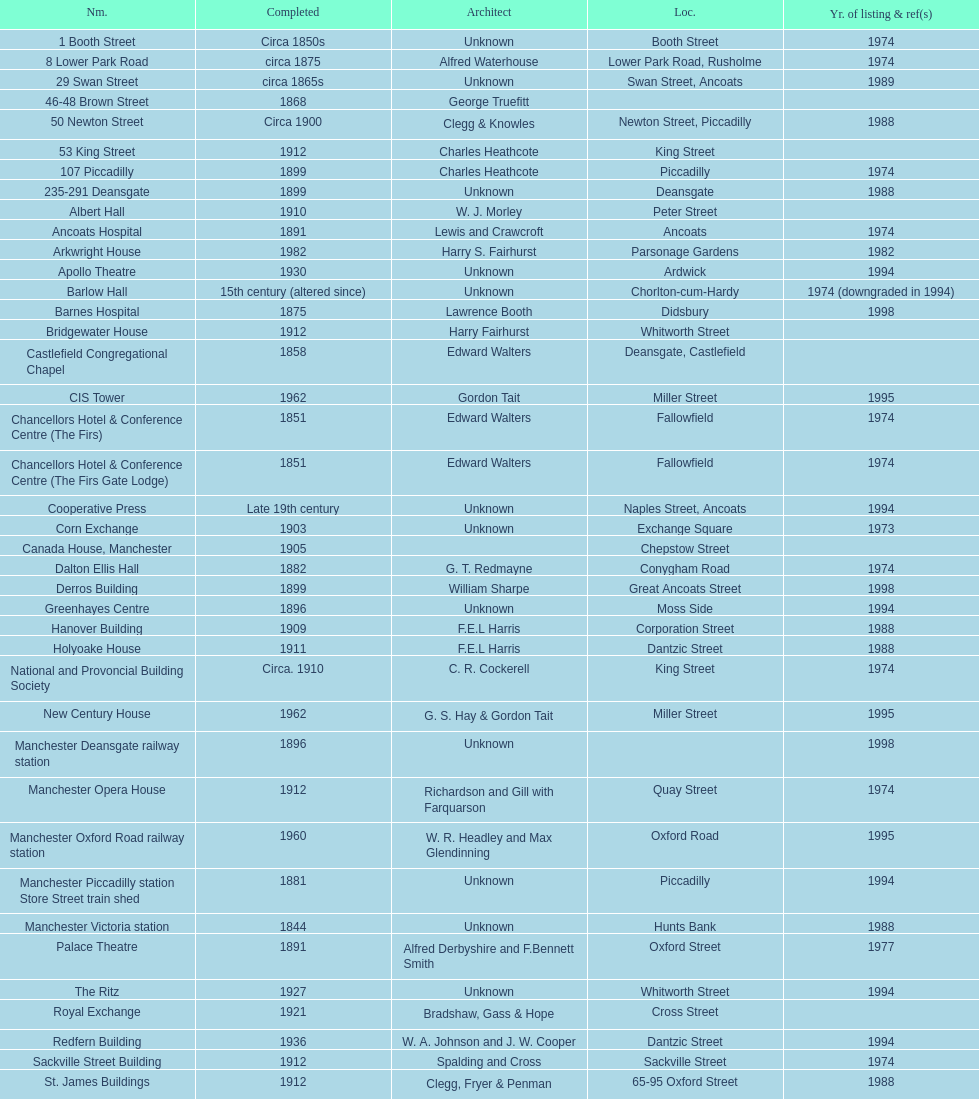Which two buildings were listed before 1974? The Old Wellington Inn, Smithfield Market Hall. Parse the table in full. {'header': ['Nm.', 'Completed', 'Architect', 'Loc.', 'Yr. of listing & ref(s)'], 'rows': [['1 Booth Street', 'Circa 1850s', 'Unknown', 'Booth Street', '1974'], ['8 Lower Park Road', 'circa 1875', 'Alfred Waterhouse', 'Lower Park Road, Rusholme', '1974'], ['29 Swan Street', 'circa 1865s', 'Unknown', 'Swan Street, Ancoats', '1989'], ['46-48 Brown Street', '1868', 'George Truefitt', '', ''], ['50 Newton Street', 'Circa 1900', 'Clegg & Knowles', 'Newton Street, Piccadilly', '1988'], ['53 King Street', '1912', 'Charles Heathcote', 'King Street', ''], ['107 Piccadilly', '1899', 'Charles Heathcote', 'Piccadilly', '1974'], ['235-291 Deansgate', '1899', 'Unknown', 'Deansgate', '1988'], ['Albert Hall', '1910', 'W. J. Morley', 'Peter Street', ''], ['Ancoats Hospital', '1891', 'Lewis and Crawcroft', 'Ancoats', '1974'], ['Arkwright House', '1982', 'Harry S. Fairhurst', 'Parsonage Gardens', '1982'], ['Apollo Theatre', '1930', 'Unknown', 'Ardwick', '1994'], ['Barlow Hall', '15th century (altered since)', 'Unknown', 'Chorlton-cum-Hardy', '1974 (downgraded in 1994)'], ['Barnes Hospital', '1875', 'Lawrence Booth', 'Didsbury', '1998'], ['Bridgewater House', '1912', 'Harry Fairhurst', 'Whitworth Street', ''], ['Castlefield Congregational Chapel', '1858', 'Edward Walters', 'Deansgate, Castlefield', ''], ['CIS Tower', '1962', 'Gordon Tait', 'Miller Street', '1995'], ['Chancellors Hotel & Conference Centre (The Firs)', '1851', 'Edward Walters', 'Fallowfield', '1974'], ['Chancellors Hotel & Conference Centre (The Firs Gate Lodge)', '1851', 'Edward Walters', 'Fallowfield', '1974'], ['Cooperative Press', 'Late 19th century', 'Unknown', 'Naples Street, Ancoats', '1994'], ['Corn Exchange', '1903', 'Unknown', 'Exchange Square', '1973'], ['Canada House, Manchester', '1905', '', 'Chepstow Street', ''], ['Dalton Ellis Hall', '1882', 'G. T. Redmayne', 'Conygham Road', '1974'], ['Derros Building', '1899', 'William Sharpe', 'Great Ancoats Street', '1998'], ['Greenhayes Centre', '1896', 'Unknown', 'Moss Side', '1994'], ['Hanover Building', '1909', 'F.E.L Harris', 'Corporation Street', '1988'], ['Holyoake House', '1911', 'F.E.L Harris', 'Dantzic Street', '1988'], ['National and Provoncial Building Society', 'Circa. 1910', 'C. R. Cockerell', 'King Street', '1974'], ['New Century House', '1962', 'G. S. Hay & Gordon Tait', 'Miller Street', '1995'], ['Manchester Deansgate railway station', '1896', 'Unknown', '', '1998'], ['Manchester Opera House', '1912', 'Richardson and Gill with Farquarson', 'Quay Street', '1974'], ['Manchester Oxford Road railway station', '1960', 'W. R. Headley and Max Glendinning', 'Oxford Road', '1995'], ['Manchester Piccadilly station Store Street train shed', '1881', 'Unknown', 'Piccadilly', '1994'], ['Manchester Victoria station', '1844', 'Unknown', 'Hunts Bank', '1988'], ['Palace Theatre', '1891', 'Alfred Derbyshire and F.Bennett Smith', 'Oxford Street', '1977'], ['The Ritz', '1927', 'Unknown', 'Whitworth Street', '1994'], ['Royal Exchange', '1921', 'Bradshaw, Gass & Hope', 'Cross Street', ''], ['Redfern Building', '1936', 'W. A. Johnson and J. W. Cooper', 'Dantzic Street', '1994'], ['Sackville Street Building', '1912', 'Spalding and Cross', 'Sackville Street', '1974'], ['St. James Buildings', '1912', 'Clegg, Fryer & Penman', '65-95 Oxford Street', '1988'], ["St Mary's Hospital", '1909', 'John Ely', 'Wilmslow Road', '1994'], ['Samuel Alexander Building', '1919', 'Percy Scott Worthington', 'Oxford Road', '2010'], ['Ship Canal House', '1927', 'Harry S. Fairhurst', 'King Street', '1982'], ['Smithfield Market Hall', '1857', 'Unknown', 'Swan Street, Ancoats', '1973'], ['Strangeways Gaol Gatehouse', '1868', 'Alfred Waterhouse', 'Sherborne Street', '1974'], ['Strangeways Prison ventilation and watch tower', '1868', 'Alfred Waterhouse', 'Sherborne Street', '1974'], ['Theatre Royal', '1845', 'Irwin and Chester', 'Peter Street', '1974'], ['Toast Rack', '1960', 'L. C. Howitt', 'Fallowfield', '1999'], ['The Old Wellington Inn', 'Mid-16th century', 'Unknown', 'Shambles Square', '1952'], ['Whitworth Park Mansions', 'Circa 1840s', 'Unknown', 'Whitworth Park', '1974']]} 